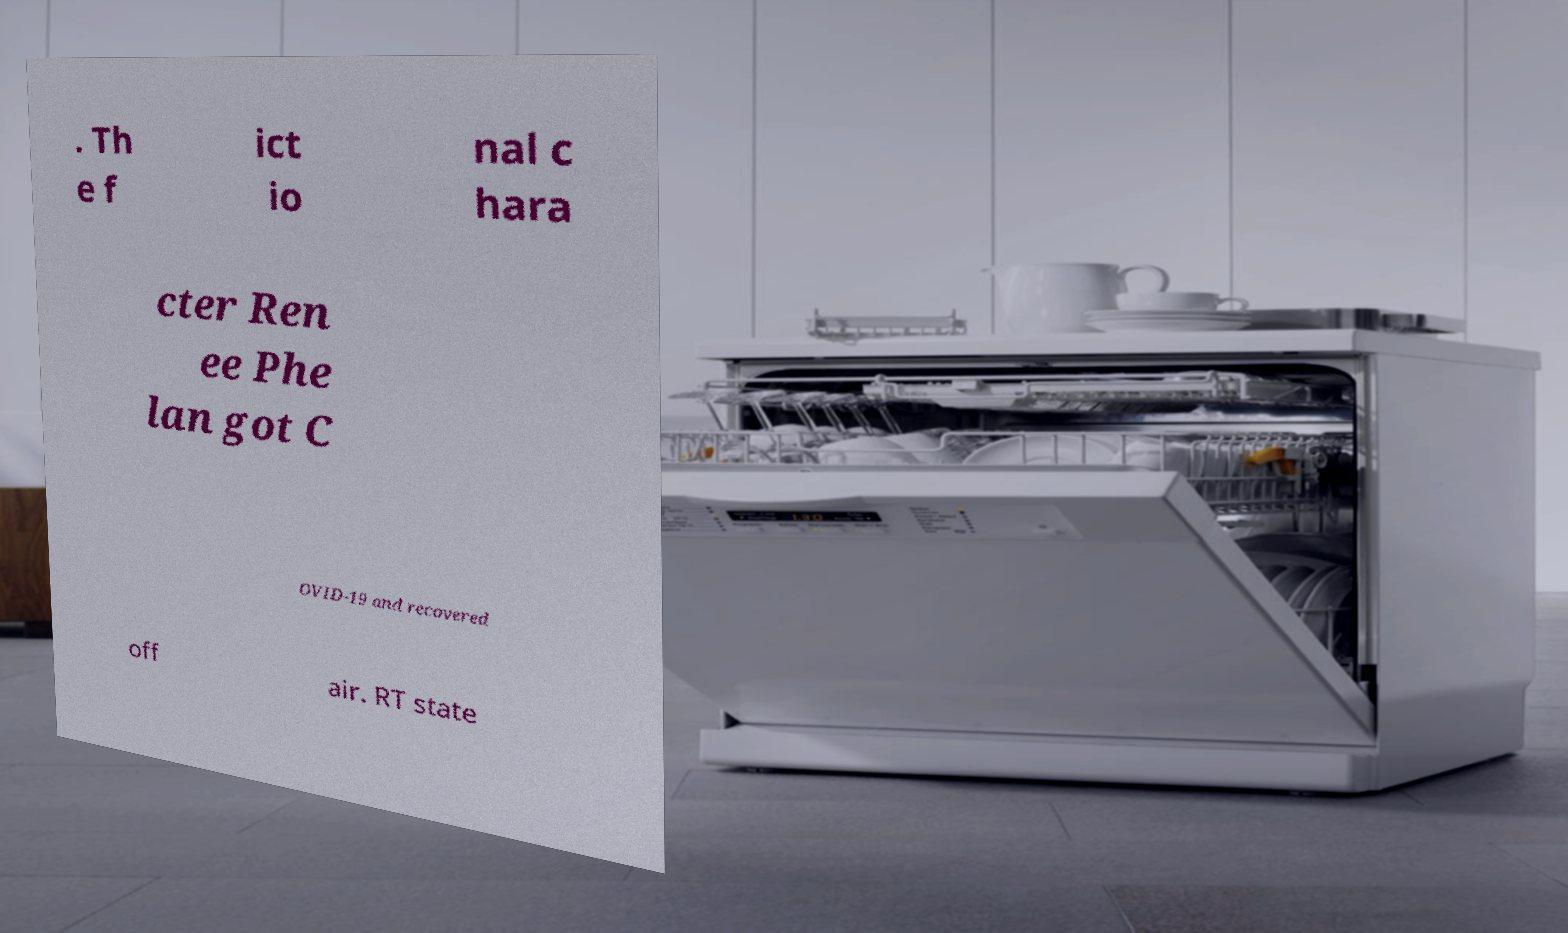Could you extract and type out the text from this image? . Th e f ict io nal c hara cter Ren ee Phe lan got C OVID-19 and recovered off air. RT state 